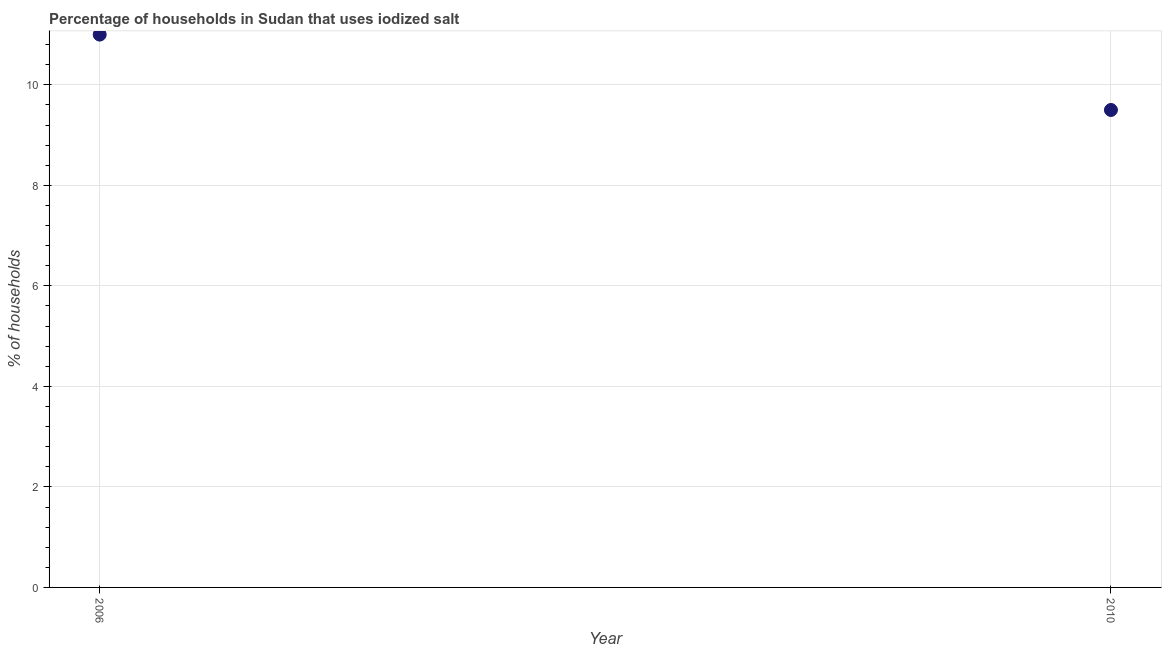What is the percentage of households where iodized salt is consumed in 2006?
Keep it short and to the point. 11. Across all years, what is the minimum percentage of households where iodized salt is consumed?
Give a very brief answer. 9.5. In which year was the percentage of households where iodized salt is consumed minimum?
Your answer should be compact. 2010. What is the sum of the percentage of households where iodized salt is consumed?
Offer a very short reply. 20.5. What is the difference between the percentage of households where iodized salt is consumed in 2006 and 2010?
Your response must be concise. 1.5. What is the average percentage of households where iodized salt is consumed per year?
Keep it short and to the point. 10.25. What is the median percentage of households where iodized salt is consumed?
Ensure brevity in your answer.  10.25. Do a majority of the years between 2006 and 2010 (inclusive) have percentage of households where iodized salt is consumed greater than 7.6 %?
Ensure brevity in your answer.  Yes. What is the ratio of the percentage of households where iodized salt is consumed in 2006 to that in 2010?
Your answer should be very brief. 1.16. In how many years, is the percentage of households where iodized salt is consumed greater than the average percentage of households where iodized salt is consumed taken over all years?
Your response must be concise. 1. How many dotlines are there?
Give a very brief answer. 1. How many years are there in the graph?
Provide a succinct answer. 2. What is the difference between two consecutive major ticks on the Y-axis?
Give a very brief answer. 2. Does the graph contain grids?
Ensure brevity in your answer.  Yes. What is the title of the graph?
Offer a terse response. Percentage of households in Sudan that uses iodized salt. What is the label or title of the X-axis?
Your response must be concise. Year. What is the label or title of the Y-axis?
Keep it short and to the point. % of households. What is the % of households in 2006?
Your response must be concise. 11. What is the % of households in 2010?
Keep it short and to the point. 9.5. What is the difference between the % of households in 2006 and 2010?
Provide a succinct answer. 1.5. What is the ratio of the % of households in 2006 to that in 2010?
Ensure brevity in your answer.  1.16. 